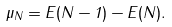Convert formula to latex. <formula><loc_0><loc_0><loc_500><loc_500>\mu _ { N } = E ( N - 1 ) - E ( N ) .</formula> 